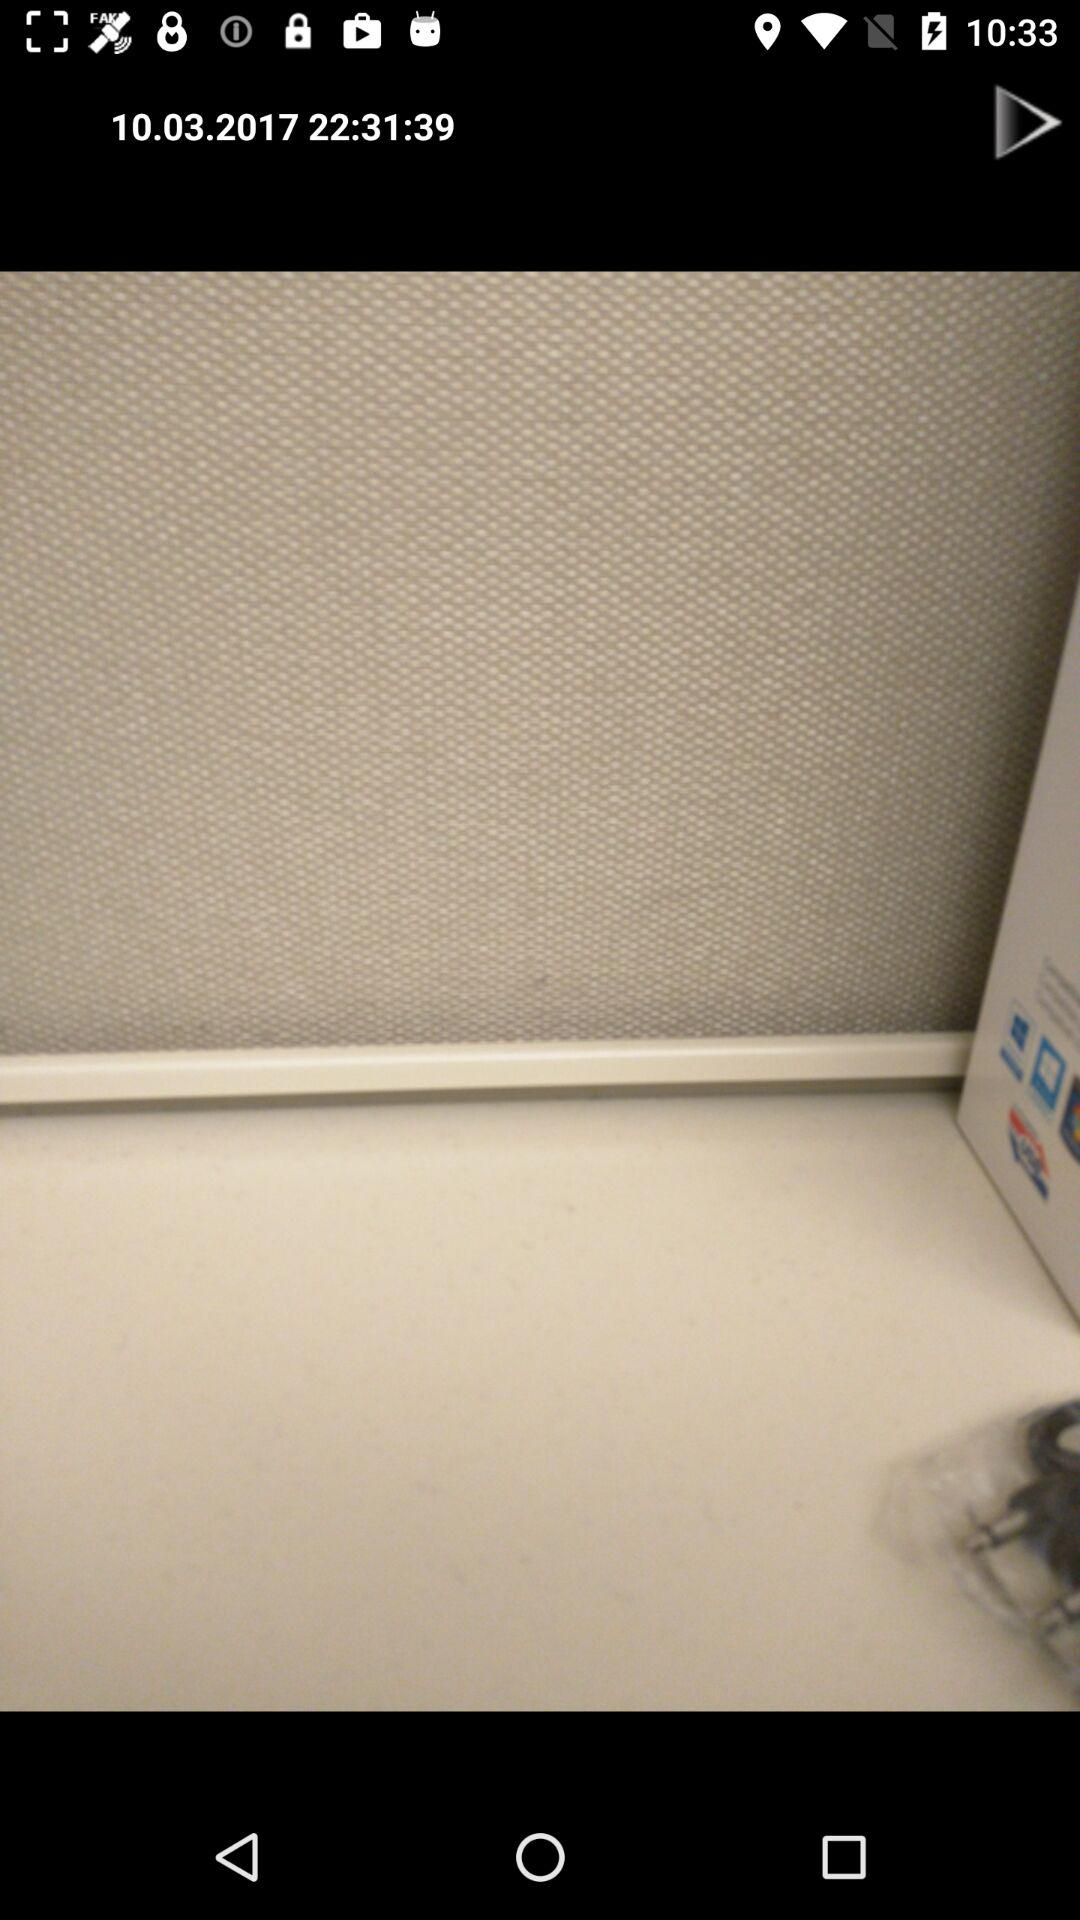What is the mentioned date? The mentioned date is October 3, 2017. 